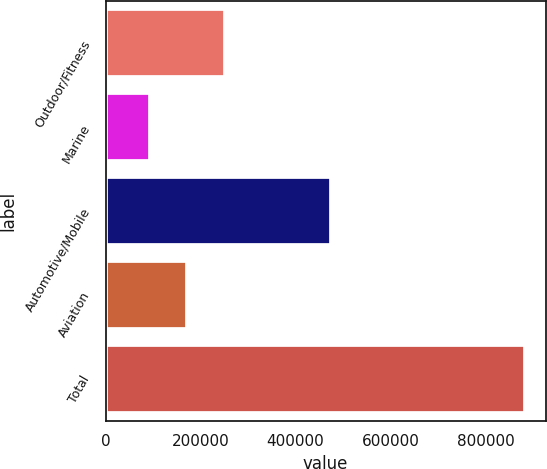Convert chart. <chart><loc_0><loc_0><loc_500><loc_500><bar_chart><fcel>Outdoor/Fitness<fcel>Marine<fcel>Automotive/Mobile<fcel>Aviation<fcel>Total<nl><fcel>250839<fcel>92952<fcel>475191<fcel>171895<fcel>882386<nl></chart> 